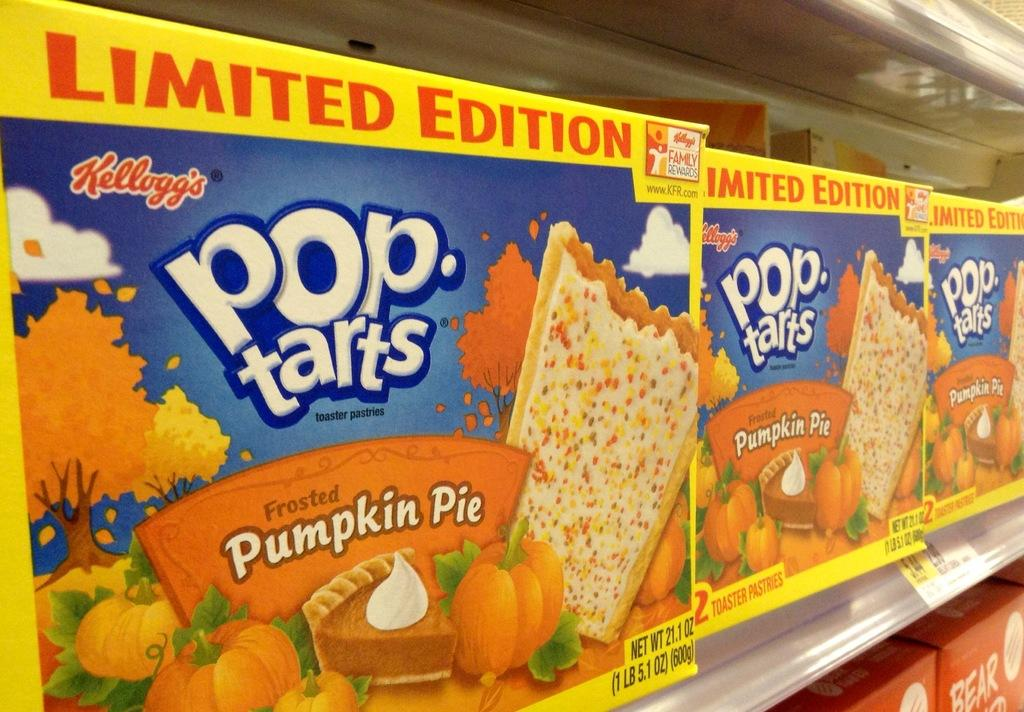What is present in the image that has images on it? There are packets with images in the image. What can be seen on the packets besides the images? There is writing on the packets. How are the packets arranged in the image? The packets are in racks. Is there any information about the cost of the packets in the image? Yes, there is a price attached to the racks. Can you describe the haircut of the person holding the packets in the image? There is no person holding the packets in the image; it only shows the packets in racks. 